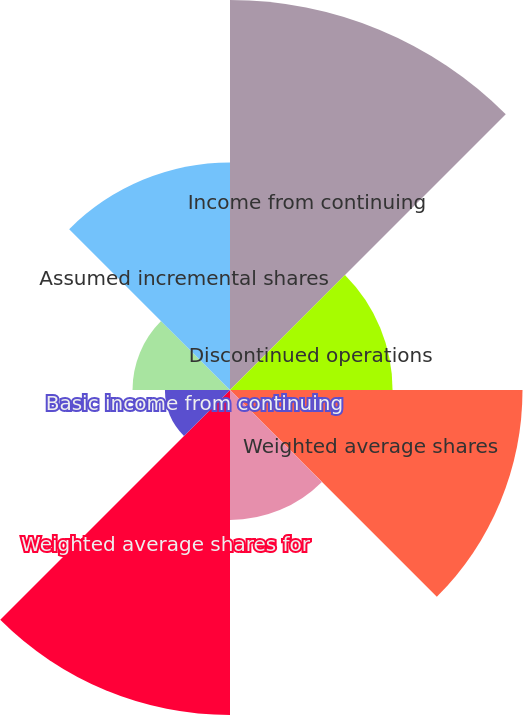Convert chart to OTSL. <chart><loc_0><loc_0><loc_500><loc_500><pie_chart><fcel>Income from continuing<fcel>Discontinued operations<fcel>Weighted average shares<fcel>Vested stock units<fcel>Weighted average shares for<fcel>Basic income from continuing<fcel>Basic net income per share<fcel>Assumed incremental shares<nl><fcel>23.08%<fcel>9.62%<fcel>17.31%<fcel>7.69%<fcel>19.23%<fcel>3.85%<fcel>5.77%<fcel>13.46%<nl></chart> 